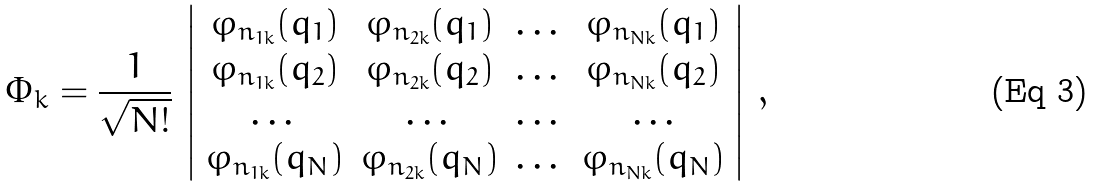Convert formula to latex. <formula><loc_0><loc_0><loc_500><loc_500>\Phi _ { k } = \frac { 1 } { \sqrt { N ! } } \, \left | \begin{array} { c c c c } \varphi _ { n _ { 1 k } } ( { q } _ { 1 } ) & \varphi _ { n _ { 2 k } } ( { q } _ { 1 } ) & \dots & \varphi _ { n _ { N k } } ( { q } _ { 1 } ) \\ \varphi _ { n _ { 1 k } } ( { q } _ { 2 } ) & \varphi _ { n _ { 2 k } } ( { q } _ { 2 } ) & \dots & \varphi _ { n _ { N k } } ( { q } _ { 2 } ) \\ \dots & \dots & \dots & \dots \\ \varphi _ { n _ { 1 k } } ( { q } _ { N } ) & \varphi _ { n _ { 2 k } } ( { q } _ { N } ) & \dots & \varphi _ { n _ { N k } } ( { q } _ { N } ) \end{array} \right | \, ,</formula> 